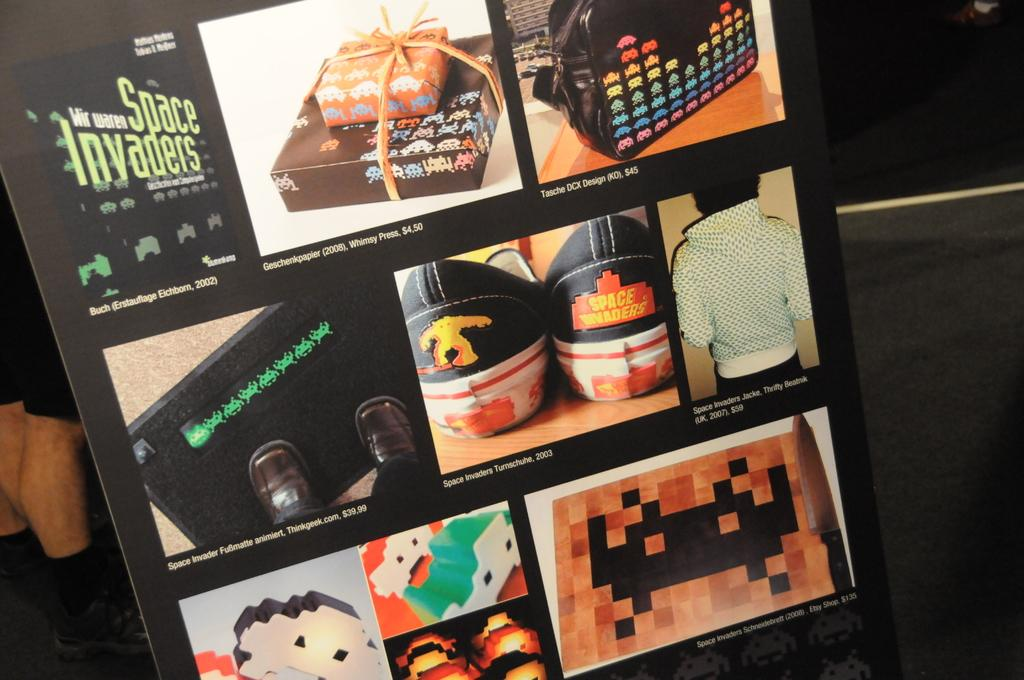<image>
Summarize the visual content of the image. Collage of images with Space Invaders in the top left. 